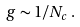<formula> <loc_0><loc_0><loc_500><loc_500>g \sim 1 / N _ { c } \, .</formula> 